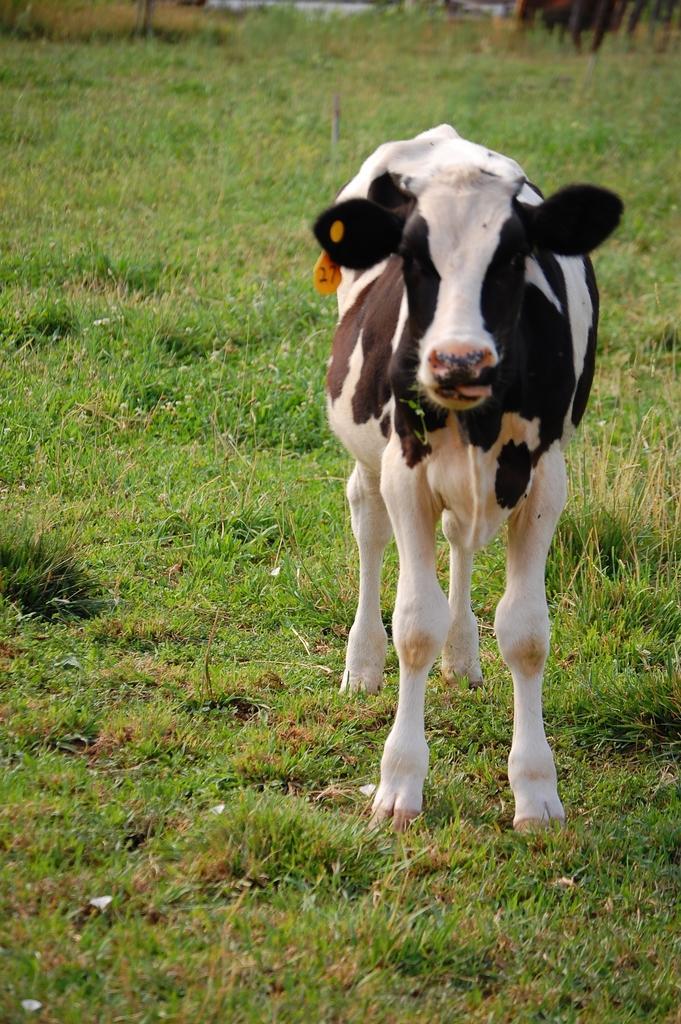Can you describe this image briefly? This image consists of a cow standing on the ground. At the bottom, there is green grass. The cow is in black and white color. 